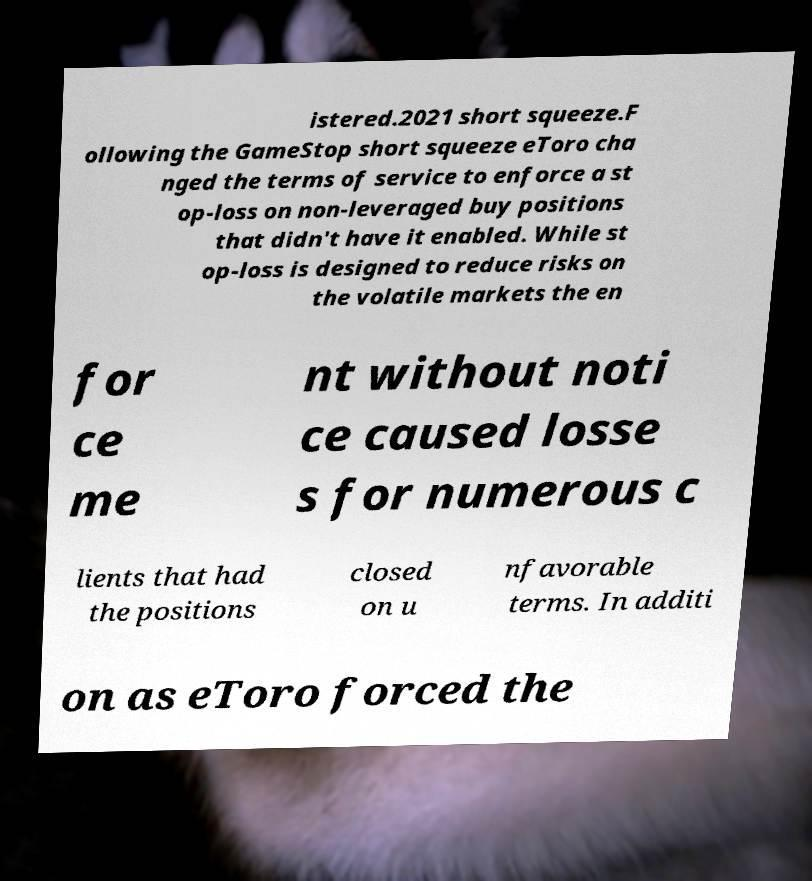Could you extract and type out the text from this image? istered.2021 short squeeze.F ollowing the GameStop short squeeze eToro cha nged the terms of service to enforce a st op-loss on non-leveraged buy positions that didn't have it enabled. While st op-loss is designed to reduce risks on the volatile markets the en for ce me nt without noti ce caused losse s for numerous c lients that had the positions closed on u nfavorable terms. In additi on as eToro forced the 